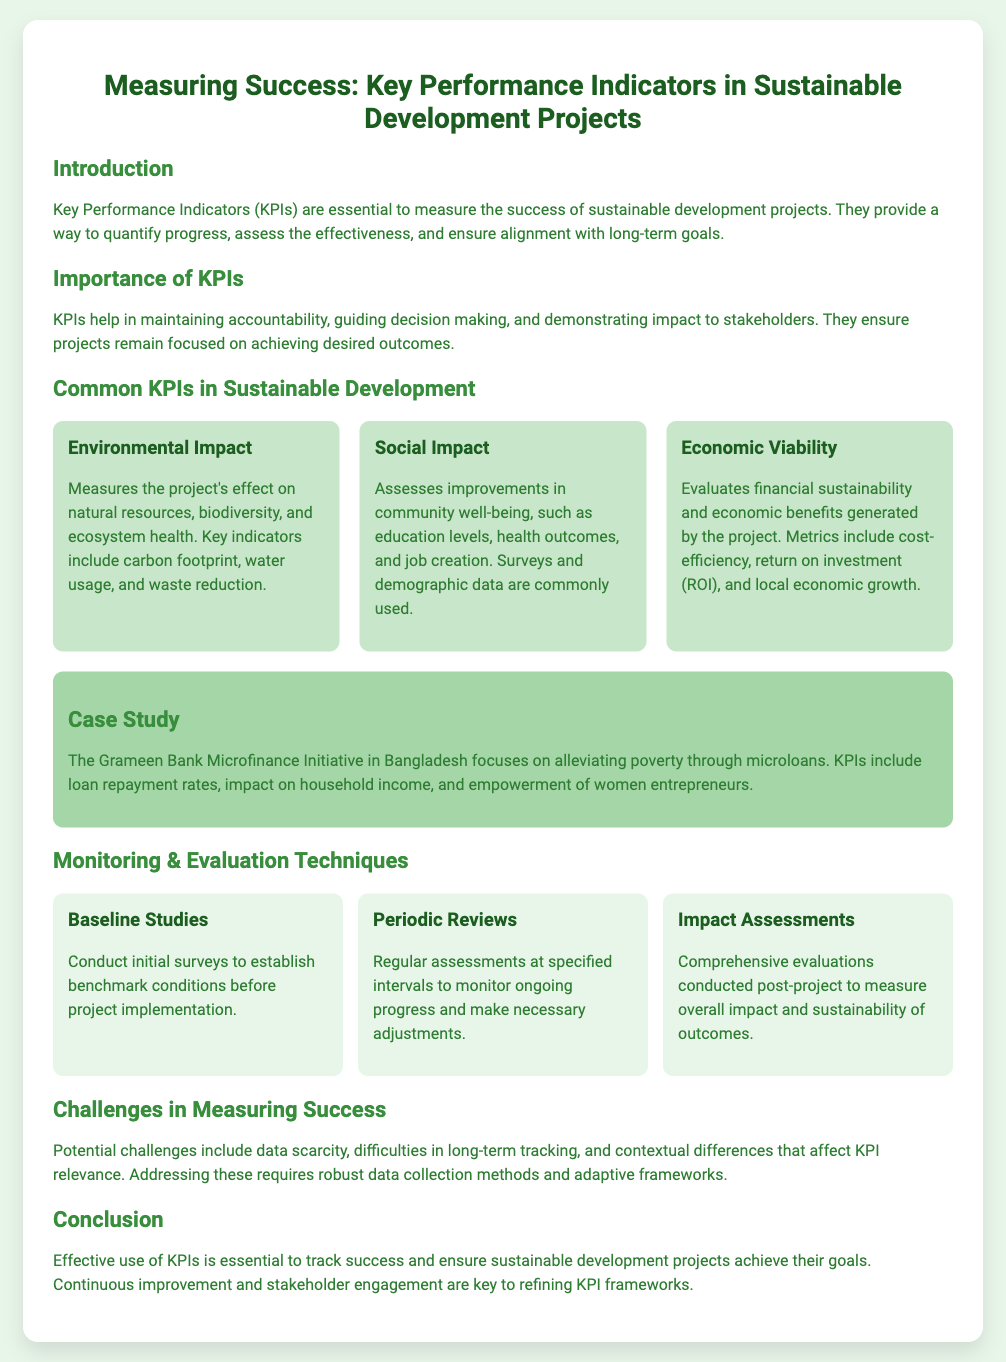What are KPIs? KPIs, or Key Performance Indicators, are essential to measure the success of sustainable development projects.
Answer: Key Performance Indicators What does the Environmental Impact KPI measure? The Environmental Impact KPI measures the project's effect on natural resources, biodiversity, and ecosystem health.
Answer: Project's effect on natural resources What is a common method for assessing Social Impact? Surveys and demographic data are commonly used to assess improvements in community well-being.
Answer: Surveys and demographic data What organization is highlighted in the Case Study? The case study highlights the Grameen Bank Microfinance Initiative in Bangladesh.
Answer: Grameen Bank Microfinance Initiative What type of study establishes benchmark conditions before project implementation? Baseline Studies conduct initial surveys to establish benchmark conditions.
Answer: Baseline Studies What challenge is mentioned in measuring success? Data scarcity is one of the challenges mentioned in the document.
Answer: Data scarcity What is a method for ongoing project progress monitoring? Periodic Reviews are regular assessments at specified intervals to monitor ongoing progress.
Answer: Periodic Reviews What is essential for refining KPI frameworks? Continuous improvement and stakeholder engagement are key to refining KPI frameworks.
Answer: Continuous improvement and stakeholder engagement 